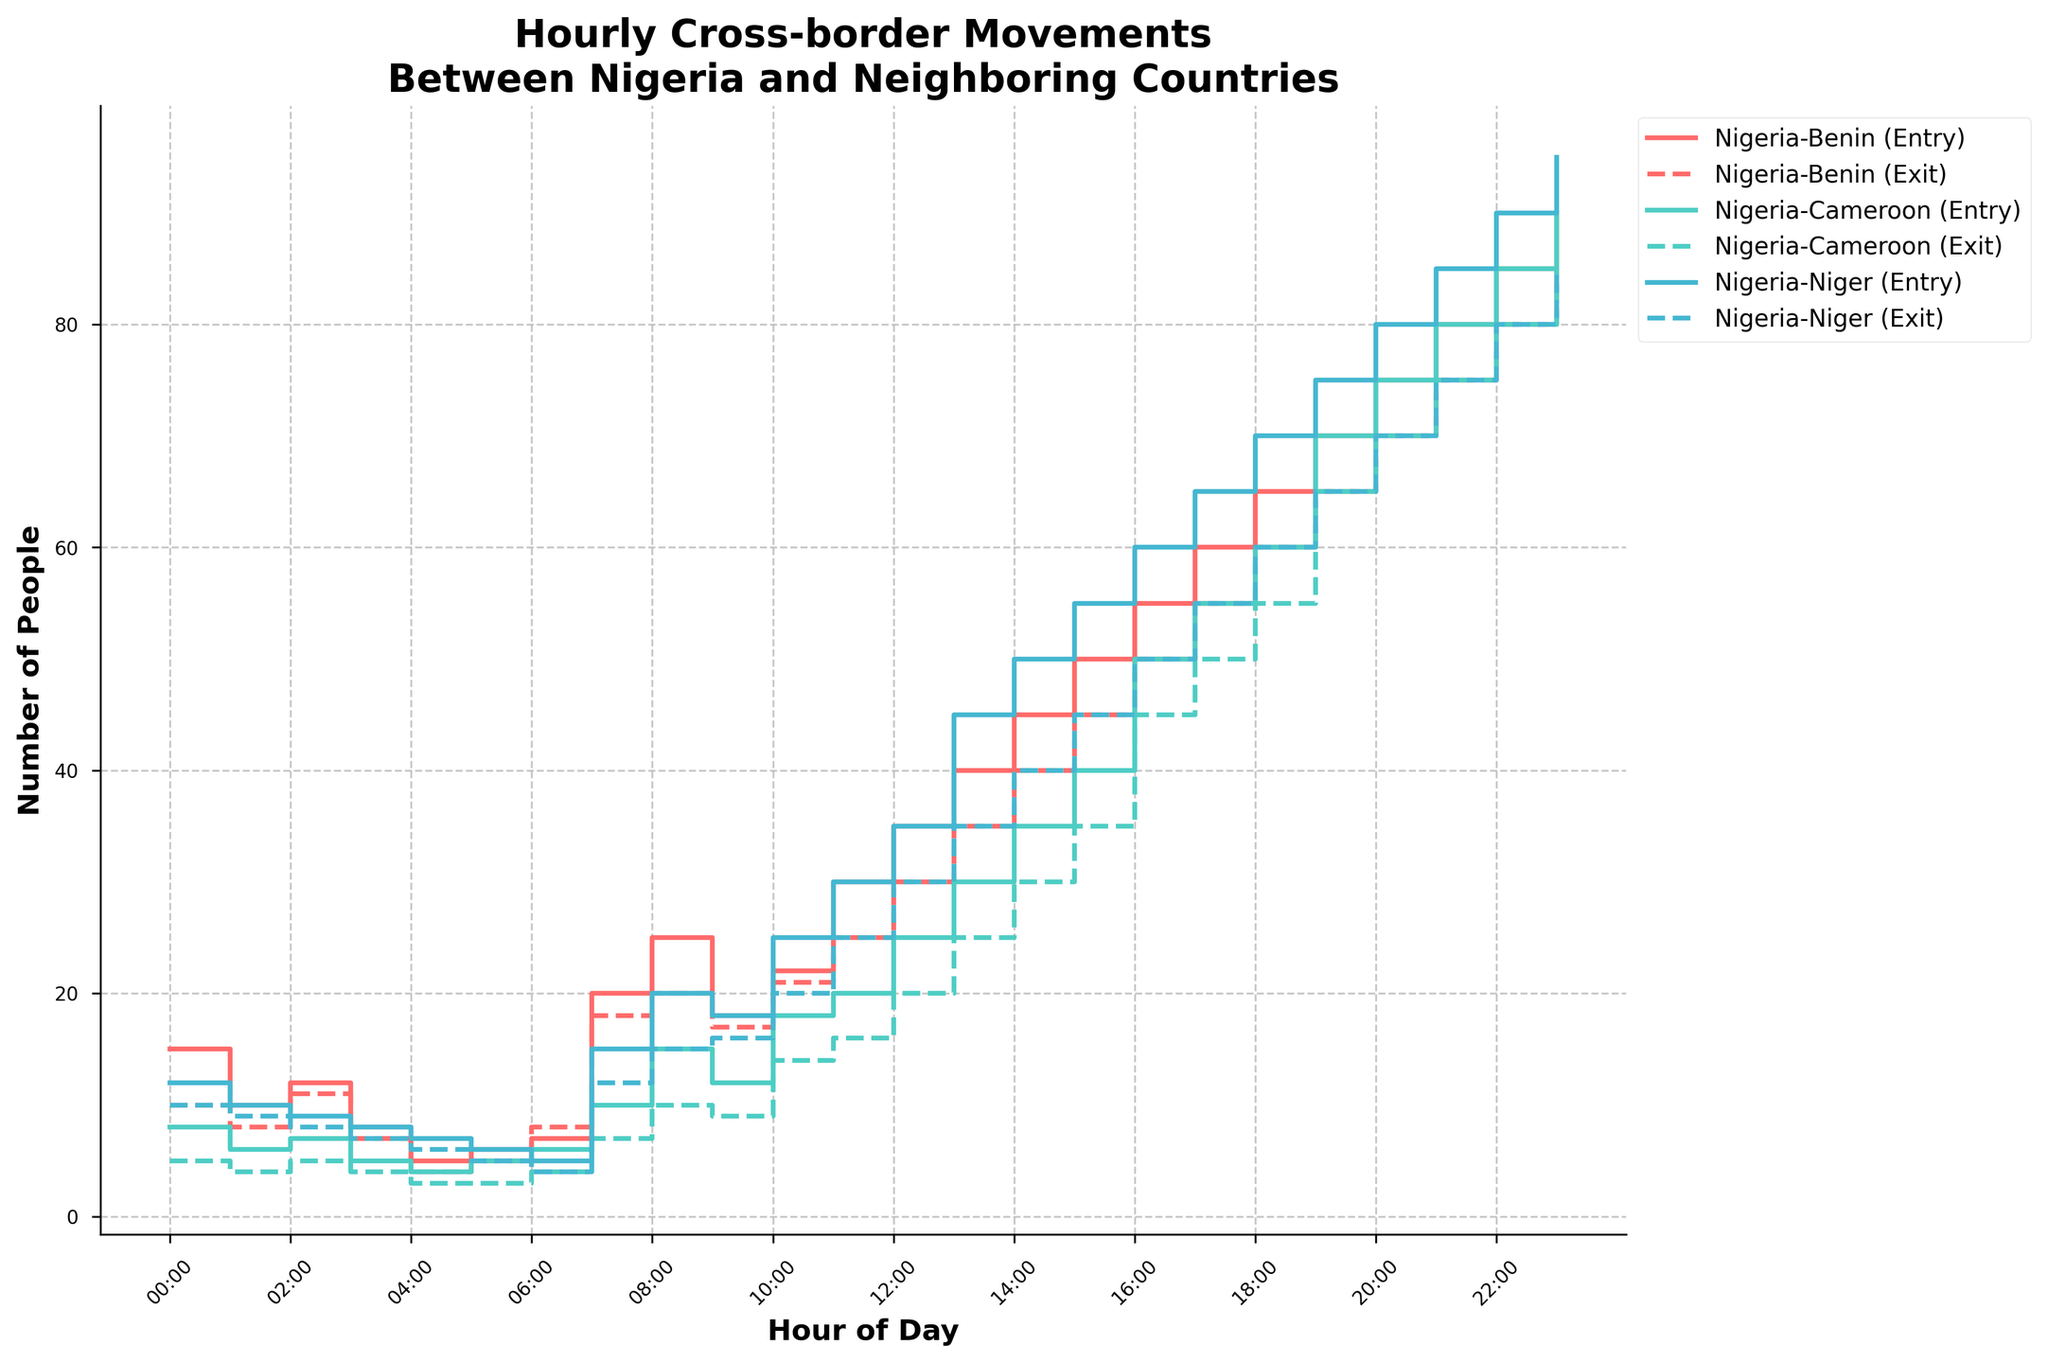What is the title of the plot? The title is located at the top of the figure and provides an overview of the plot's subject. It reads, "Hourly Cross-border Movements Between Nigeria and Neighboring Countries".
Answer: Hourly Cross-border Movements Between Nigeria and Neighboring Countries What are the borders represented in the plot? The borders can be identified by examining the legend of the plot, which lists the borders involved. The borders are Nigeria-Benin, Nigeria-Cameroon, and Nigeria-Niger.
Answer: Nigeria-Benin, Nigeria-Cameroon, Nigeria-Niger Which border shows the highest entry count at 12:00? Observe the stair steps at the 12:00 mark for each border. The Nigeria-Benin border has the highest count at 35 entries.
Answer: Nigeria-Benin At which hour is the entry count the highest for the Nigeria-Cameroon border? Following the stair step pattern for Nigeria-Cameroon, the highest entry count is observed at 23:00 with 90 entries.
Answer: 23:00 What is the approximate difference in entry counts between the Nigeria-Niger and Nigeria-Benin borders at 08:00? Look at the entry counts at 08:00 for both borders. Nigeria-Niger has 20 entries, and Nigeria-Benin has 25 entries. The difference is 25 - 20 = 5.
Answer: 5 How do the entry counts compare to exit counts at 19:00 for the Nigeria-Niger border? At 19:00, check the stair steps for both the entry and exit counts for Nigeria-Niger. The entry count is 75 and the exit count is 65. Entries are greater by 75 - 65 = 10.
Answer: Entries are greater by 10 What trend can be observed in the entry and exit counts for Nigeria-Benin from 00:00 to 08:00? Track the stair step patterns from 00:00 to 08:00 for Nigeria-Benin. Both entry and exit counts show an upward trend starting from lower values (15 and 10) and increasing to higher values (25 and 20).
Answer: Increasing trend Which border has an entry count of 10 at both the 01:00 and 23:00 hours? Review the stair step records for an entry count of 10 at these hours. The Nigeria-Niger border has an entry count of 10 at 01:00 and 10 between 23:00 and 24:00 due to an increase.
Answer: Nigeria-Niger 